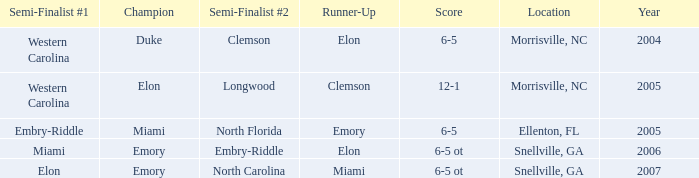When Embry-Riddle made it to the first semi finalist slot, list all the runners up. Emory. 